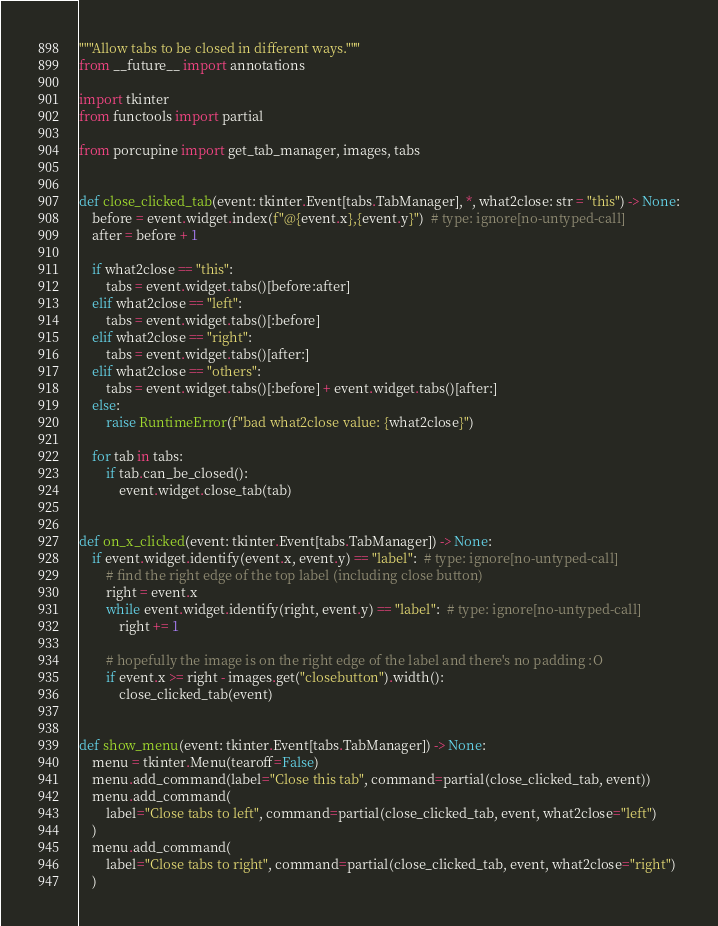Convert code to text. <code><loc_0><loc_0><loc_500><loc_500><_Python_>"""Allow tabs to be closed in different ways."""
from __future__ import annotations

import tkinter
from functools import partial

from porcupine import get_tab_manager, images, tabs


def close_clicked_tab(event: tkinter.Event[tabs.TabManager], *, what2close: str = "this") -> None:
    before = event.widget.index(f"@{event.x},{event.y}")  # type: ignore[no-untyped-call]
    after = before + 1

    if what2close == "this":
        tabs = event.widget.tabs()[before:after]
    elif what2close == "left":
        tabs = event.widget.tabs()[:before]
    elif what2close == "right":
        tabs = event.widget.tabs()[after:]
    elif what2close == "others":
        tabs = event.widget.tabs()[:before] + event.widget.tabs()[after:]
    else:
        raise RuntimeError(f"bad what2close value: {what2close}")

    for tab in tabs:
        if tab.can_be_closed():
            event.widget.close_tab(tab)


def on_x_clicked(event: tkinter.Event[tabs.TabManager]) -> None:
    if event.widget.identify(event.x, event.y) == "label":  # type: ignore[no-untyped-call]
        # find the right edge of the top label (including close button)
        right = event.x
        while event.widget.identify(right, event.y) == "label":  # type: ignore[no-untyped-call]
            right += 1

        # hopefully the image is on the right edge of the label and there's no padding :O
        if event.x >= right - images.get("closebutton").width():
            close_clicked_tab(event)


def show_menu(event: tkinter.Event[tabs.TabManager]) -> None:
    menu = tkinter.Menu(tearoff=False)
    menu.add_command(label="Close this tab", command=partial(close_clicked_tab, event))
    menu.add_command(
        label="Close tabs to left", command=partial(close_clicked_tab, event, what2close="left")
    )
    menu.add_command(
        label="Close tabs to right", command=partial(close_clicked_tab, event, what2close="right")
    )</code> 